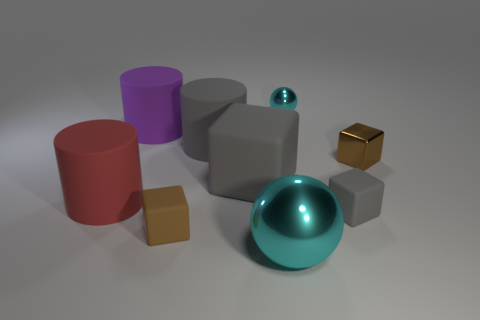What shape is the big purple rubber object?
Keep it short and to the point. Cylinder. What is the size of the rubber object that is in front of the big gray block and behind the small gray rubber cube?
Offer a very short reply. Large. There is a gray block to the right of the small cyan thing; what is it made of?
Your answer should be very brief. Rubber. There is a small shiny ball; is it the same color as the rubber cube behind the big red object?
Make the answer very short. No. How many things are either cylinders on the right side of the large purple object or cyan objects to the left of the small cyan shiny sphere?
Your answer should be compact. 2. There is a block that is on the left side of the big cyan shiny ball and right of the tiny brown rubber block; what color is it?
Your answer should be compact. Gray. Are there more big balls than tiny brown blocks?
Your response must be concise. No. There is a gray matte object right of the tiny cyan shiny object; is it the same shape as the red rubber object?
Offer a terse response. No. How many metallic things are tiny brown things or red objects?
Keep it short and to the point. 1. Are there any big red cylinders that have the same material as the small gray object?
Your response must be concise. Yes. 